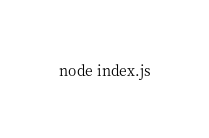Convert code to text. <code><loc_0><loc_0><loc_500><loc_500><_Bash_>node index.js

</code> 